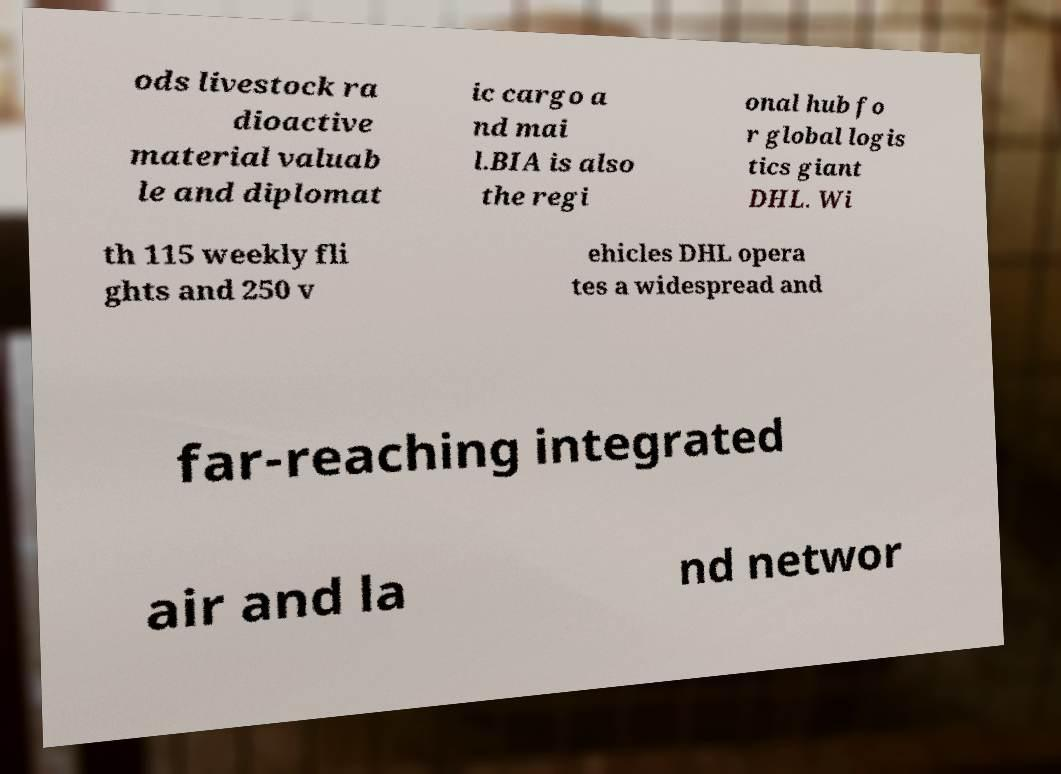I need the written content from this picture converted into text. Can you do that? ods livestock ra dioactive material valuab le and diplomat ic cargo a nd mai l.BIA is also the regi onal hub fo r global logis tics giant DHL. Wi th 115 weekly fli ghts and 250 v ehicles DHL opera tes a widespread and far-reaching integrated air and la nd networ 